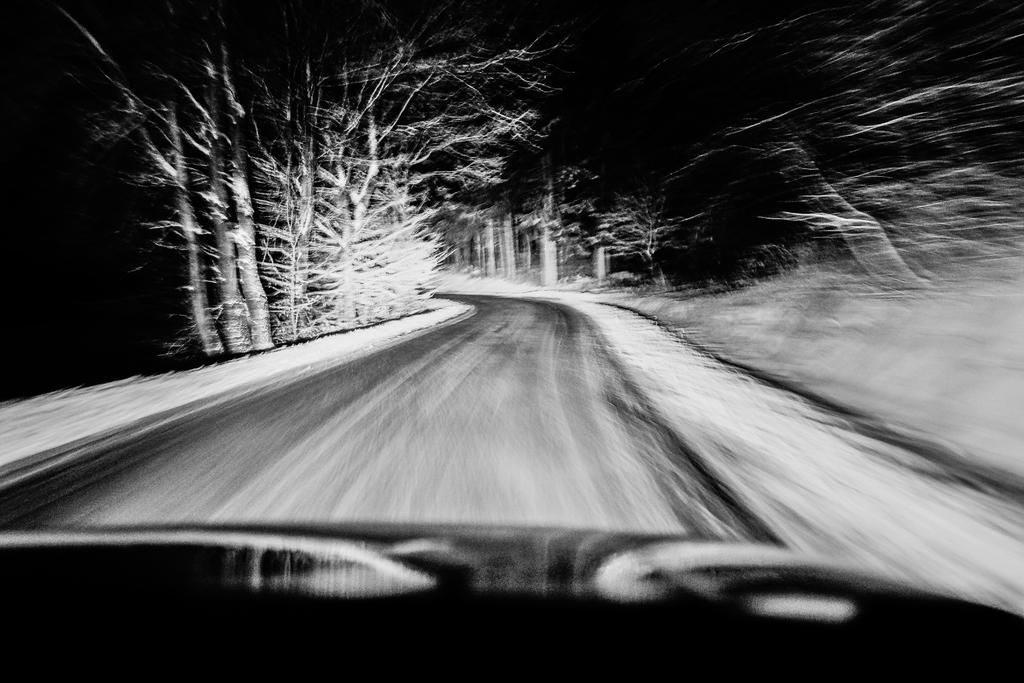What is located in the middle of the image? There is a road in the middle of the image. What can be seen in the background of the image? There are trees in the background of the image. What type of church can be seen in the image? There is no church present in the image; it features a road and trees in the background. How much money is being exchanged in the image? There is no mention of money or any transaction in the image. 